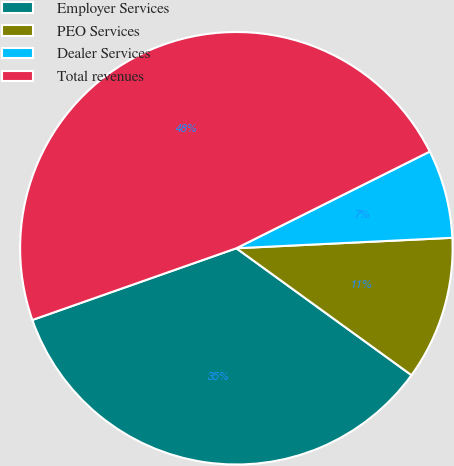Convert chart to OTSL. <chart><loc_0><loc_0><loc_500><loc_500><pie_chart><fcel>Employer Services<fcel>PEO Services<fcel>Dealer Services<fcel>Total revenues<nl><fcel>34.64%<fcel>10.75%<fcel>6.61%<fcel>48.0%<nl></chart> 